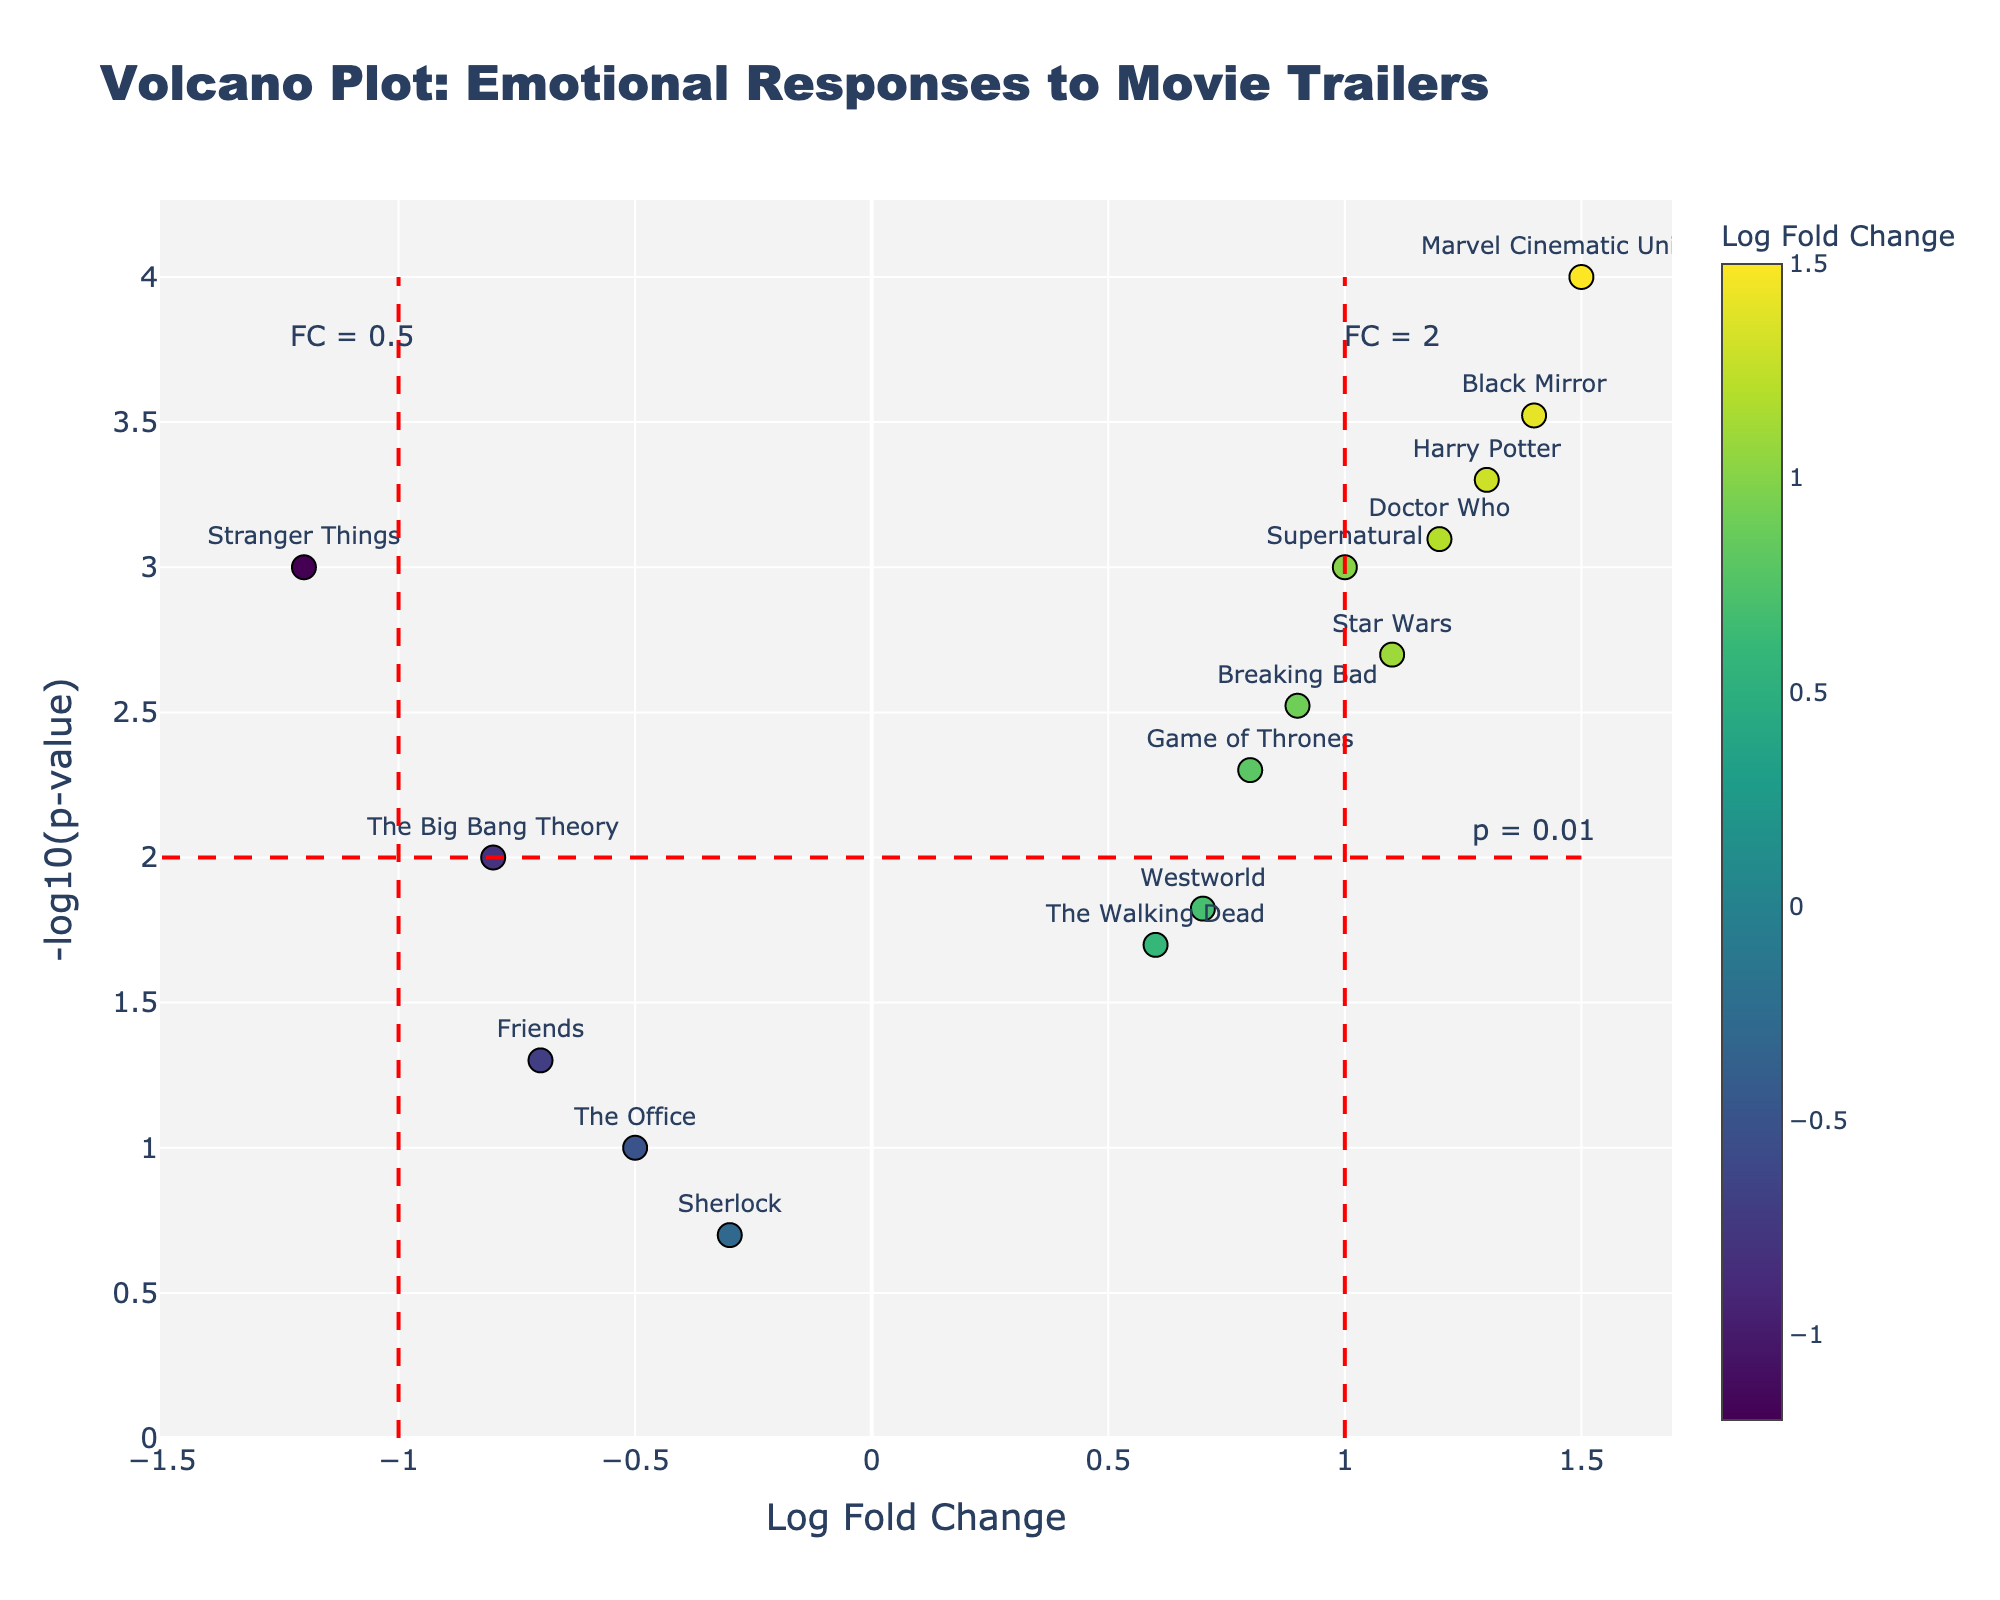What is the title of the plot? The title of the plot is displayed at the top. It is clearly written as 'Volcano Plot: Emotional Responses to Movie Trailers'.
Answer: Volcano Plot: Emotional Responses to Movie Trailers Which TV show has the highest log fold change (LogFoldChange) value? To determine which TV show has the highest log fold change, look for the data point farthest to the right on the x-axis. 'Marvel Cinematic Universe' has the highest log fold change of 1.5.
Answer: Marvel Cinematic Universe Which TV show has the lowest p-value? To find the lowest p-value, we need the highest value on the y-axis (-log10(p-value)). The data point farthest up is 'Marvel Cinematic Universe', hence it has the lowest p-value.
Answer: Marvel Cinematic Universe How many TV shows have log fold change values greater than 1? Locate all points that are to the right of the vertical red line at x=1 on the x-axis. There are six such points: 'Marvel Cinematic Universe', 'Star Wars', 'Harry Potter', 'Supernatural', 'Doctor Who', and 'Black Mirror'.
Answer: 6 Which TV show with a significant p-value (p<0.01) has the smallest log fold change? Significant p-values correspond to points above the horizontal red line at y=-log10(0.01)≈2. Among these, the smallest log fold change is the data point farthest left, which is 'Stranger Things' with a log fold change of -1.2.
Answer: Stranger Things How many TV shows have non-significant p-values (p>=0.01)? Non-significant p-values correspond to points below the horizontal red line at y=-log10(0.01)≈2. There are four such points: 'The Office', 'Friends', 'The Walking Dead', and 'Sherlock'.
Answer: 4 Which data points fall within the range of -1<=LogFoldChange<=1 and p<0.01? Points within this range lie between the two vertical red lines (-1 and 1) and above the horizontal red line (significant p-value). The points meeting these criteria are 'Stranger Things', 'Game of Thrones', and 'Breaking Bad'.
Answer: Stranger Things, Game of Thrones, Breaking Bad Which TV show is closest to the significance threshold for p-value (p=0.01, y=-log10(0.01)=2)? The TV show whose data point lies closest to the horizontal red line (y=2) represents the threshold. Here, 'The Walking Dead' is closest to this threshold.
Answer: The Walking Dead 